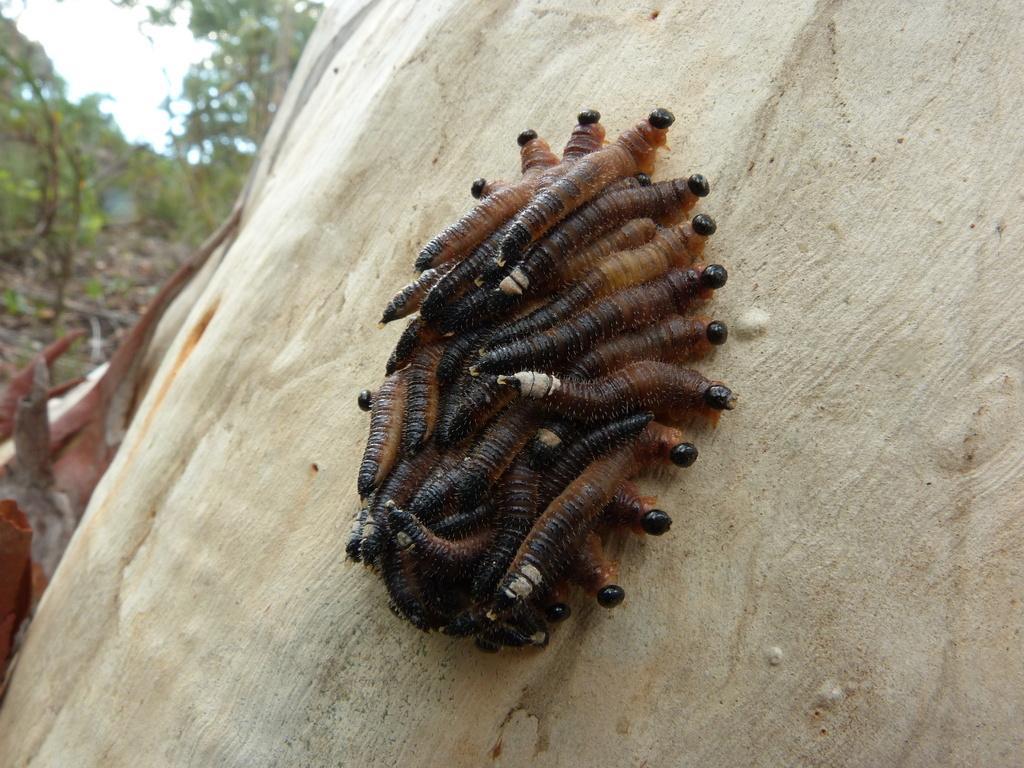Please provide a concise description of this image. In this image there are group of worms on the surface which is white in colour and in the background there are trees and in the center there is an object which is brown in colour. 